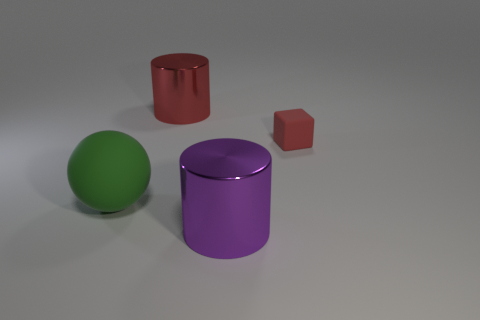What colors are the objects in the image, and what are their shapes? The image showcases objects in three distinct colors: green, red, and purple. Their shapes are equally varied, featuring a sphere, a cube, and two cylinders. 